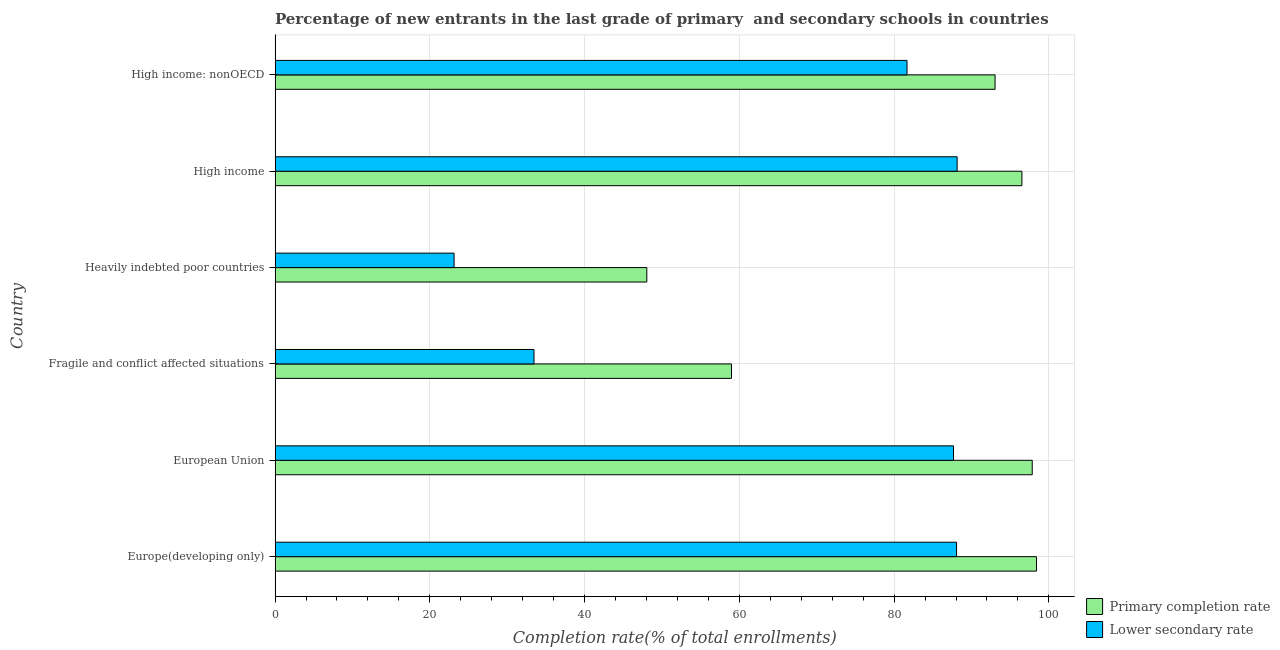Are the number of bars per tick equal to the number of legend labels?
Provide a succinct answer. Yes. How many bars are there on the 5th tick from the top?
Your answer should be compact. 2. What is the label of the 4th group of bars from the top?
Ensure brevity in your answer.  Fragile and conflict affected situations. In how many cases, is the number of bars for a given country not equal to the number of legend labels?
Offer a very short reply. 0. What is the completion rate in secondary schools in European Union?
Provide a short and direct response. 87.67. Across all countries, what is the maximum completion rate in secondary schools?
Your answer should be very brief. 88.15. Across all countries, what is the minimum completion rate in primary schools?
Provide a succinct answer. 48.04. In which country was the completion rate in primary schools maximum?
Offer a terse response. Europe(developing only). In which country was the completion rate in primary schools minimum?
Your answer should be compact. Heavily indebted poor countries. What is the total completion rate in secondary schools in the graph?
Provide a succinct answer. 402.15. What is the difference between the completion rate in secondary schools in European Union and that in Heavily indebted poor countries?
Provide a short and direct response. 64.54. What is the difference between the completion rate in secondary schools in Heavily indebted poor countries and the completion rate in primary schools in High income: nonOECD?
Give a very brief answer. -69.92. What is the average completion rate in primary schools per country?
Provide a short and direct response. 82.14. What is the difference between the completion rate in secondary schools and completion rate in primary schools in Europe(developing only)?
Make the answer very short. -10.33. What is the ratio of the completion rate in primary schools in Fragile and conflict affected situations to that in High income?
Offer a very short reply. 0.61. What is the difference between the highest and the second highest completion rate in primary schools?
Your answer should be compact. 0.55. What is the difference between the highest and the lowest completion rate in primary schools?
Provide a succinct answer. 50.36. In how many countries, is the completion rate in secondary schools greater than the average completion rate in secondary schools taken over all countries?
Offer a terse response. 4. Is the sum of the completion rate in primary schools in Europe(developing only) and European Union greater than the maximum completion rate in secondary schools across all countries?
Provide a short and direct response. Yes. What does the 1st bar from the top in Fragile and conflict affected situations represents?
Offer a terse response. Lower secondary rate. What does the 1st bar from the bottom in Fragile and conflict affected situations represents?
Make the answer very short. Primary completion rate. Are all the bars in the graph horizontal?
Your answer should be compact. Yes. How many countries are there in the graph?
Provide a succinct answer. 6. Does the graph contain grids?
Your answer should be very brief. Yes. How many legend labels are there?
Provide a short and direct response. 2. What is the title of the graph?
Provide a short and direct response. Percentage of new entrants in the last grade of primary  and secondary schools in countries. Does "Researchers" appear as one of the legend labels in the graph?
Make the answer very short. No. What is the label or title of the X-axis?
Make the answer very short. Completion rate(% of total enrollments). What is the Completion rate(% of total enrollments) in Primary completion rate in Europe(developing only)?
Offer a terse response. 98.4. What is the Completion rate(% of total enrollments) in Lower secondary rate in Europe(developing only)?
Your answer should be very brief. 88.07. What is the Completion rate(% of total enrollments) of Primary completion rate in European Union?
Keep it short and to the point. 97.85. What is the Completion rate(% of total enrollments) of Lower secondary rate in European Union?
Ensure brevity in your answer.  87.67. What is the Completion rate(% of total enrollments) in Primary completion rate in Fragile and conflict affected situations?
Give a very brief answer. 58.98. What is the Completion rate(% of total enrollments) of Lower secondary rate in Fragile and conflict affected situations?
Offer a very short reply. 33.46. What is the Completion rate(% of total enrollments) in Primary completion rate in Heavily indebted poor countries?
Make the answer very short. 48.04. What is the Completion rate(% of total enrollments) of Lower secondary rate in Heavily indebted poor countries?
Give a very brief answer. 23.13. What is the Completion rate(% of total enrollments) of Primary completion rate in High income?
Ensure brevity in your answer.  96.52. What is the Completion rate(% of total enrollments) of Lower secondary rate in High income?
Provide a succinct answer. 88.15. What is the Completion rate(% of total enrollments) of Primary completion rate in High income: nonOECD?
Ensure brevity in your answer.  93.05. What is the Completion rate(% of total enrollments) in Lower secondary rate in High income: nonOECD?
Offer a terse response. 81.67. Across all countries, what is the maximum Completion rate(% of total enrollments) in Primary completion rate?
Make the answer very short. 98.4. Across all countries, what is the maximum Completion rate(% of total enrollments) in Lower secondary rate?
Provide a short and direct response. 88.15. Across all countries, what is the minimum Completion rate(% of total enrollments) of Primary completion rate?
Offer a terse response. 48.04. Across all countries, what is the minimum Completion rate(% of total enrollments) in Lower secondary rate?
Keep it short and to the point. 23.13. What is the total Completion rate(% of total enrollments) in Primary completion rate in the graph?
Offer a terse response. 492.85. What is the total Completion rate(% of total enrollments) in Lower secondary rate in the graph?
Keep it short and to the point. 402.15. What is the difference between the Completion rate(% of total enrollments) in Primary completion rate in Europe(developing only) and that in European Union?
Keep it short and to the point. 0.55. What is the difference between the Completion rate(% of total enrollments) in Lower secondary rate in Europe(developing only) and that in European Union?
Give a very brief answer. 0.4. What is the difference between the Completion rate(% of total enrollments) of Primary completion rate in Europe(developing only) and that in Fragile and conflict affected situations?
Keep it short and to the point. 39.42. What is the difference between the Completion rate(% of total enrollments) of Lower secondary rate in Europe(developing only) and that in Fragile and conflict affected situations?
Keep it short and to the point. 54.61. What is the difference between the Completion rate(% of total enrollments) of Primary completion rate in Europe(developing only) and that in Heavily indebted poor countries?
Give a very brief answer. 50.36. What is the difference between the Completion rate(% of total enrollments) of Lower secondary rate in Europe(developing only) and that in Heavily indebted poor countries?
Your response must be concise. 64.94. What is the difference between the Completion rate(% of total enrollments) of Primary completion rate in Europe(developing only) and that in High income?
Provide a succinct answer. 1.89. What is the difference between the Completion rate(% of total enrollments) of Lower secondary rate in Europe(developing only) and that in High income?
Keep it short and to the point. -0.08. What is the difference between the Completion rate(% of total enrollments) in Primary completion rate in Europe(developing only) and that in High income: nonOECD?
Your answer should be very brief. 5.36. What is the difference between the Completion rate(% of total enrollments) in Lower secondary rate in Europe(developing only) and that in High income: nonOECD?
Your answer should be compact. 6.4. What is the difference between the Completion rate(% of total enrollments) in Primary completion rate in European Union and that in Fragile and conflict affected situations?
Provide a short and direct response. 38.87. What is the difference between the Completion rate(% of total enrollments) in Lower secondary rate in European Union and that in Fragile and conflict affected situations?
Keep it short and to the point. 54.21. What is the difference between the Completion rate(% of total enrollments) of Primary completion rate in European Union and that in Heavily indebted poor countries?
Your response must be concise. 49.81. What is the difference between the Completion rate(% of total enrollments) of Lower secondary rate in European Union and that in Heavily indebted poor countries?
Provide a succinct answer. 64.54. What is the difference between the Completion rate(% of total enrollments) in Primary completion rate in European Union and that in High income?
Offer a terse response. 1.34. What is the difference between the Completion rate(% of total enrollments) of Lower secondary rate in European Union and that in High income?
Provide a short and direct response. -0.47. What is the difference between the Completion rate(% of total enrollments) of Primary completion rate in European Union and that in High income: nonOECD?
Your answer should be very brief. 4.8. What is the difference between the Completion rate(% of total enrollments) of Lower secondary rate in European Union and that in High income: nonOECD?
Your answer should be compact. 6.01. What is the difference between the Completion rate(% of total enrollments) in Primary completion rate in Fragile and conflict affected situations and that in Heavily indebted poor countries?
Give a very brief answer. 10.94. What is the difference between the Completion rate(% of total enrollments) in Lower secondary rate in Fragile and conflict affected situations and that in Heavily indebted poor countries?
Give a very brief answer. 10.33. What is the difference between the Completion rate(% of total enrollments) of Primary completion rate in Fragile and conflict affected situations and that in High income?
Make the answer very short. -37.53. What is the difference between the Completion rate(% of total enrollments) in Lower secondary rate in Fragile and conflict affected situations and that in High income?
Offer a terse response. -54.69. What is the difference between the Completion rate(% of total enrollments) of Primary completion rate in Fragile and conflict affected situations and that in High income: nonOECD?
Make the answer very short. -34.06. What is the difference between the Completion rate(% of total enrollments) in Lower secondary rate in Fragile and conflict affected situations and that in High income: nonOECD?
Make the answer very short. -48.21. What is the difference between the Completion rate(% of total enrollments) in Primary completion rate in Heavily indebted poor countries and that in High income?
Provide a short and direct response. -48.47. What is the difference between the Completion rate(% of total enrollments) of Lower secondary rate in Heavily indebted poor countries and that in High income?
Provide a succinct answer. -65.01. What is the difference between the Completion rate(% of total enrollments) of Primary completion rate in Heavily indebted poor countries and that in High income: nonOECD?
Ensure brevity in your answer.  -45.01. What is the difference between the Completion rate(% of total enrollments) of Lower secondary rate in Heavily indebted poor countries and that in High income: nonOECD?
Your answer should be compact. -58.54. What is the difference between the Completion rate(% of total enrollments) in Primary completion rate in High income and that in High income: nonOECD?
Ensure brevity in your answer.  3.47. What is the difference between the Completion rate(% of total enrollments) in Lower secondary rate in High income and that in High income: nonOECD?
Offer a very short reply. 6.48. What is the difference between the Completion rate(% of total enrollments) in Primary completion rate in Europe(developing only) and the Completion rate(% of total enrollments) in Lower secondary rate in European Union?
Your answer should be compact. 10.73. What is the difference between the Completion rate(% of total enrollments) of Primary completion rate in Europe(developing only) and the Completion rate(% of total enrollments) of Lower secondary rate in Fragile and conflict affected situations?
Offer a very short reply. 64.94. What is the difference between the Completion rate(% of total enrollments) of Primary completion rate in Europe(developing only) and the Completion rate(% of total enrollments) of Lower secondary rate in Heavily indebted poor countries?
Your answer should be compact. 75.27. What is the difference between the Completion rate(% of total enrollments) in Primary completion rate in Europe(developing only) and the Completion rate(% of total enrollments) in Lower secondary rate in High income?
Offer a terse response. 10.26. What is the difference between the Completion rate(% of total enrollments) of Primary completion rate in Europe(developing only) and the Completion rate(% of total enrollments) of Lower secondary rate in High income: nonOECD?
Provide a short and direct response. 16.74. What is the difference between the Completion rate(% of total enrollments) in Primary completion rate in European Union and the Completion rate(% of total enrollments) in Lower secondary rate in Fragile and conflict affected situations?
Your answer should be compact. 64.39. What is the difference between the Completion rate(% of total enrollments) in Primary completion rate in European Union and the Completion rate(% of total enrollments) in Lower secondary rate in Heavily indebted poor countries?
Your response must be concise. 74.72. What is the difference between the Completion rate(% of total enrollments) of Primary completion rate in European Union and the Completion rate(% of total enrollments) of Lower secondary rate in High income?
Provide a short and direct response. 9.71. What is the difference between the Completion rate(% of total enrollments) in Primary completion rate in European Union and the Completion rate(% of total enrollments) in Lower secondary rate in High income: nonOECD?
Keep it short and to the point. 16.18. What is the difference between the Completion rate(% of total enrollments) in Primary completion rate in Fragile and conflict affected situations and the Completion rate(% of total enrollments) in Lower secondary rate in Heavily indebted poor countries?
Your answer should be compact. 35.85. What is the difference between the Completion rate(% of total enrollments) in Primary completion rate in Fragile and conflict affected situations and the Completion rate(% of total enrollments) in Lower secondary rate in High income?
Give a very brief answer. -29.16. What is the difference between the Completion rate(% of total enrollments) in Primary completion rate in Fragile and conflict affected situations and the Completion rate(% of total enrollments) in Lower secondary rate in High income: nonOECD?
Offer a terse response. -22.68. What is the difference between the Completion rate(% of total enrollments) of Primary completion rate in Heavily indebted poor countries and the Completion rate(% of total enrollments) of Lower secondary rate in High income?
Make the answer very short. -40.1. What is the difference between the Completion rate(% of total enrollments) of Primary completion rate in Heavily indebted poor countries and the Completion rate(% of total enrollments) of Lower secondary rate in High income: nonOECD?
Your response must be concise. -33.63. What is the difference between the Completion rate(% of total enrollments) of Primary completion rate in High income and the Completion rate(% of total enrollments) of Lower secondary rate in High income: nonOECD?
Keep it short and to the point. 14.85. What is the average Completion rate(% of total enrollments) of Primary completion rate per country?
Offer a terse response. 82.14. What is the average Completion rate(% of total enrollments) in Lower secondary rate per country?
Give a very brief answer. 67.03. What is the difference between the Completion rate(% of total enrollments) of Primary completion rate and Completion rate(% of total enrollments) of Lower secondary rate in Europe(developing only)?
Keep it short and to the point. 10.33. What is the difference between the Completion rate(% of total enrollments) of Primary completion rate and Completion rate(% of total enrollments) of Lower secondary rate in European Union?
Provide a short and direct response. 10.18. What is the difference between the Completion rate(% of total enrollments) of Primary completion rate and Completion rate(% of total enrollments) of Lower secondary rate in Fragile and conflict affected situations?
Give a very brief answer. 25.52. What is the difference between the Completion rate(% of total enrollments) in Primary completion rate and Completion rate(% of total enrollments) in Lower secondary rate in Heavily indebted poor countries?
Give a very brief answer. 24.91. What is the difference between the Completion rate(% of total enrollments) in Primary completion rate and Completion rate(% of total enrollments) in Lower secondary rate in High income?
Make the answer very short. 8.37. What is the difference between the Completion rate(% of total enrollments) in Primary completion rate and Completion rate(% of total enrollments) in Lower secondary rate in High income: nonOECD?
Give a very brief answer. 11.38. What is the ratio of the Completion rate(% of total enrollments) of Primary completion rate in Europe(developing only) to that in European Union?
Provide a succinct answer. 1.01. What is the ratio of the Completion rate(% of total enrollments) of Primary completion rate in Europe(developing only) to that in Fragile and conflict affected situations?
Give a very brief answer. 1.67. What is the ratio of the Completion rate(% of total enrollments) of Lower secondary rate in Europe(developing only) to that in Fragile and conflict affected situations?
Give a very brief answer. 2.63. What is the ratio of the Completion rate(% of total enrollments) in Primary completion rate in Europe(developing only) to that in Heavily indebted poor countries?
Offer a terse response. 2.05. What is the ratio of the Completion rate(% of total enrollments) of Lower secondary rate in Europe(developing only) to that in Heavily indebted poor countries?
Your response must be concise. 3.81. What is the ratio of the Completion rate(% of total enrollments) in Primary completion rate in Europe(developing only) to that in High income?
Give a very brief answer. 1.02. What is the ratio of the Completion rate(% of total enrollments) in Primary completion rate in Europe(developing only) to that in High income: nonOECD?
Provide a succinct answer. 1.06. What is the ratio of the Completion rate(% of total enrollments) of Lower secondary rate in Europe(developing only) to that in High income: nonOECD?
Make the answer very short. 1.08. What is the ratio of the Completion rate(% of total enrollments) of Primary completion rate in European Union to that in Fragile and conflict affected situations?
Ensure brevity in your answer.  1.66. What is the ratio of the Completion rate(% of total enrollments) of Lower secondary rate in European Union to that in Fragile and conflict affected situations?
Provide a succinct answer. 2.62. What is the ratio of the Completion rate(% of total enrollments) of Primary completion rate in European Union to that in Heavily indebted poor countries?
Offer a very short reply. 2.04. What is the ratio of the Completion rate(% of total enrollments) in Lower secondary rate in European Union to that in Heavily indebted poor countries?
Ensure brevity in your answer.  3.79. What is the ratio of the Completion rate(% of total enrollments) of Primary completion rate in European Union to that in High income?
Keep it short and to the point. 1.01. What is the ratio of the Completion rate(% of total enrollments) in Primary completion rate in European Union to that in High income: nonOECD?
Offer a very short reply. 1.05. What is the ratio of the Completion rate(% of total enrollments) in Lower secondary rate in European Union to that in High income: nonOECD?
Keep it short and to the point. 1.07. What is the ratio of the Completion rate(% of total enrollments) in Primary completion rate in Fragile and conflict affected situations to that in Heavily indebted poor countries?
Your answer should be compact. 1.23. What is the ratio of the Completion rate(% of total enrollments) in Lower secondary rate in Fragile and conflict affected situations to that in Heavily indebted poor countries?
Offer a terse response. 1.45. What is the ratio of the Completion rate(% of total enrollments) of Primary completion rate in Fragile and conflict affected situations to that in High income?
Offer a terse response. 0.61. What is the ratio of the Completion rate(% of total enrollments) of Lower secondary rate in Fragile and conflict affected situations to that in High income?
Make the answer very short. 0.38. What is the ratio of the Completion rate(% of total enrollments) in Primary completion rate in Fragile and conflict affected situations to that in High income: nonOECD?
Make the answer very short. 0.63. What is the ratio of the Completion rate(% of total enrollments) of Lower secondary rate in Fragile and conflict affected situations to that in High income: nonOECD?
Offer a very short reply. 0.41. What is the ratio of the Completion rate(% of total enrollments) in Primary completion rate in Heavily indebted poor countries to that in High income?
Your response must be concise. 0.5. What is the ratio of the Completion rate(% of total enrollments) in Lower secondary rate in Heavily indebted poor countries to that in High income?
Your response must be concise. 0.26. What is the ratio of the Completion rate(% of total enrollments) in Primary completion rate in Heavily indebted poor countries to that in High income: nonOECD?
Provide a succinct answer. 0.52. What is the ratio of the Completion rate(% of total enrollments) of Lower secondary rate in Heavily indebted poor countries to that in High income: nonOECD?
Your answer should be compact. 0.28. What is the ratio of the Completion rate(% of total enrollments) in Primary completion rate in High income to that in High income: nonOECD?
Offer a very short reply. 1.04. What is the ratio of the Completion rate(% of total enrollments) of Lower secondary rate in High income to that in High income: nonOECD?
Ensure brevity in your answer.  1.08. What is the difference between the highest and the second highest Completion rate(% of total enrollments) of Primary completion rate?
Provide a short and direct response. 0.55. What is the difference between the highest and the second highest Completion rate(% of total enrollments) of Lower secondary rate?
Keep it short and to the point. 0.08. What is the difference between the highest and the lowest Completion rate(% of total enrollments) in Primary completion rate?
Provide a short and direct response. 50.36. What is the difference between the highest and the lowest Completion rate(% of total enrollments) of Lower secondary rate?
Provide a succinct answer. 65.01. 